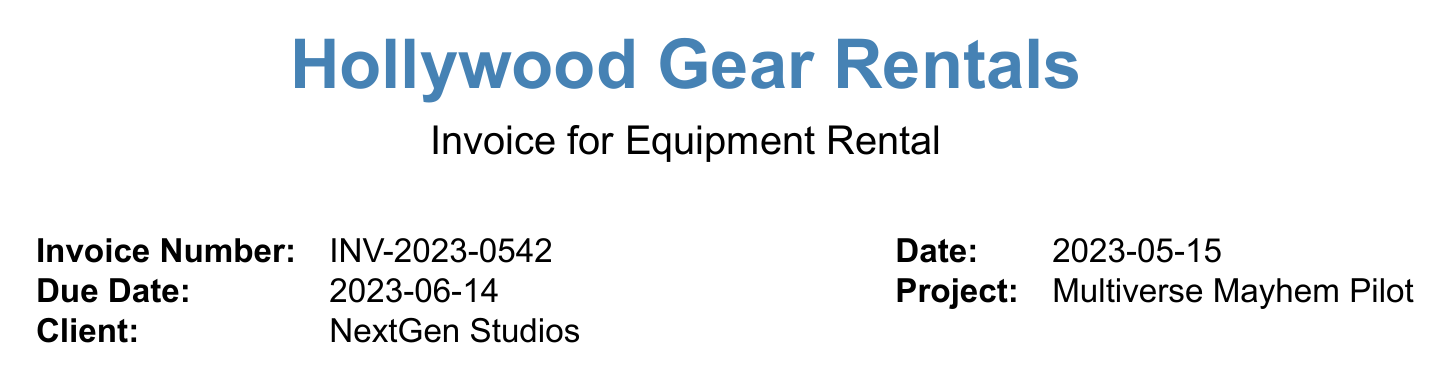what is the invoice number? The invoice number is listed at the top of the document and identifies this specific invoice.
Answer: INV-2023-0542 what is the total cost for the cameras? The total cost for cameras is calculated by summing up the individual totals for each camera listed in the invoice.
Answer: $28,450 how many Sennheiser MKH 416 Shotgun Microphones were rented? The quantity of Sennheiser MKH 416 Shotgun Microphones is clearly stated in the sound equipment section of the document.
Answer: 2 what is the due date for the invoice? The due date is specified in the invoice details section, which indicates when payment is required.
Answer: 2023-06-14 what is the subtotal of the invoice? The subtotal is highlighted in the totals section and reflects the cost before adding tax.
Answer: $78,660 how much is the tax amount? The tax amount is derived from applying the tax rate to the subtotal, and is detailed in the totals section of the invoice.
Answer: $6,882.75 what specific project is this invoice for? The project name is provided in the invoice details, which is key information for tracking services rendered.
Answer: Multiverse Mayhem Pilot how many days were the equipment rented for? The number of days for the rental is consistently indicated throughout the equipment list and totals.
Answer: 7 what is the daily rate for the DJI Ronin 2? The daily rate for the DJI Ronin 2 is outlined in the multi-platform accessories section of the equipment list.
Answer: $300 